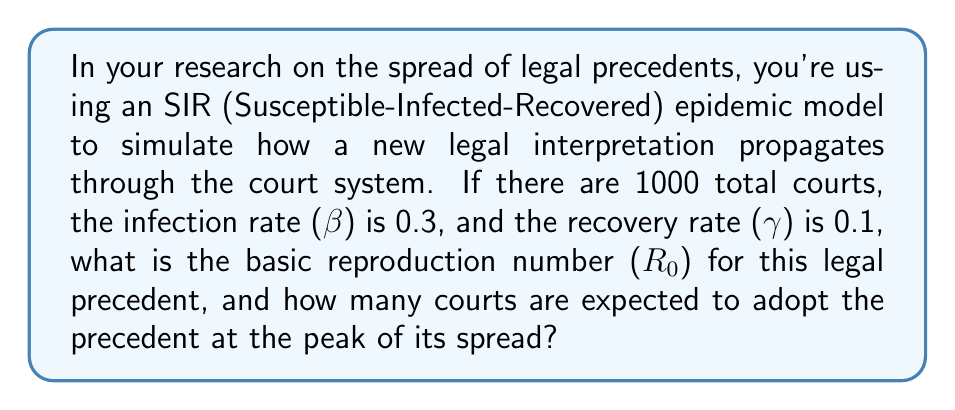Can you answer this question? To solve this problem, we'll follow these steps:

1. Calculate the basic reproduction number (R₀):
   The basic reproduction number is given by the formula:
   $$R_0 = \frac{\beta}{\gamma}$$
   Where β is the infection rate and γ is the recovery rate.
   $$R_0 = \frac{0.3}{0.1} = 3$$

2. Calculate the maximum number of infected courts:
   In an SIR model, the maximum number of infected individuals (or in this case, courts) occurs when:
   $$I_{max} = N(1 - \frac{1}{R_0} - \frac{\ln R_0}{R_0})$$
   Where N is the total population (total number of courts).

   Substituting the values:
   $$I_{max} = 1000(1 - \frac{1}{3} - \frac{\ln 3}{3})$$

3. Simplify the calculation:
   $$I_{max} = 1000(1 - 0.3333 - 0.3662)$$
   $$I_{max} = 1000(0.3005)$$
   $$I_{max} = 300.5$$

4. Round to the nearest whole number:
   Since we can't have a fractional number of courts, we round to 301 courts.
Answer: R₀ = 3; 301 courts 